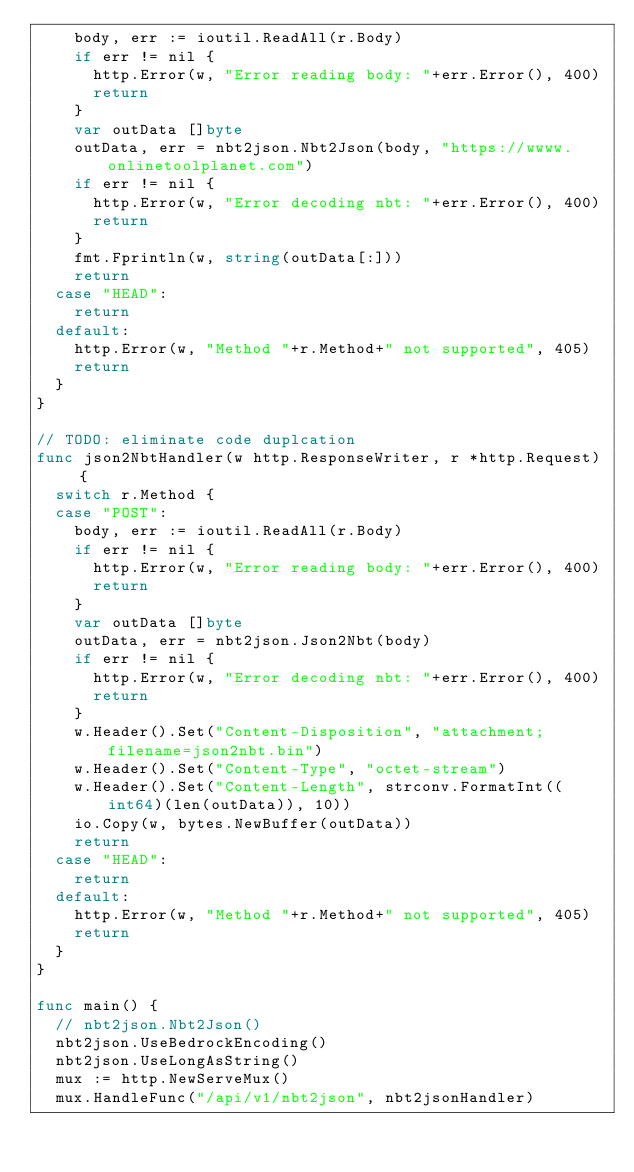Convert code to text. <code><loc_0><loc_0><loc_500><loc_500><_Go_>		body, err := ioutil.ReadAll(r.Body)
		if err != nil {
			http.Error(w, "Error reading body: "+err.Error(), 400)
			return
		}
		var outData []byte
		outData, err = nbt2json.Nbt2Json(body, "https://wwww.onlinetoolplanet.com")
		if err != nil {
			http.Error(w, "Error decoding nbt: "+err.Error(), 400)
			return
		}
		fmt.Fprintln(w, string(outData[:]))
		return
	case "HEAD":
		return
	default:
		http.Error(w, "Method "+r.Method+" not supported", 405)
		return
	}
}

// TODO: eliminate code duplcation
func json2NbtHandler(w http.ResponseWriter, r *http.Request) {
	switch r.Method {
	case "POST":
		body, err := ioutil.ReadAll(r.Body)
		if err != nil {
			http.Error(w, "Error reading body: "+err.Error(), 400)
			return
		}
		var outData []byte
		outData, err = nbt2json.Json2Nbt(body)
		if err != nil {
			http.Error(w, "Error decoding nbt: "+err.Error(), 400)
			return
		}
		w.Header().Set("Content-Disposition", "attachment; filename=json2nbt.bin")
		w.Header().Set("Content-Type", "octet-stream")
		w.Header().Set("Content-Length", strconv.FormatInt((int64)(len(outData)), 10))
		io.Copy(w, bytes.NewBuffer(outData))
		return
	case "HEAD":
		return
	default:
		http.Error(w, "Method "+r.Method+" not supported", 405)
		return
	}
}

func main() {
	// nbt2json.Nbt2Json()
	nbt2json.UseBedrockEncoding()
	nbt2json.UseLongAsString()
	mux := http.NewServeMux()
	mux.HandleFunc("/api/v1/nbt2json", nbt2jsonHandler)</code> 